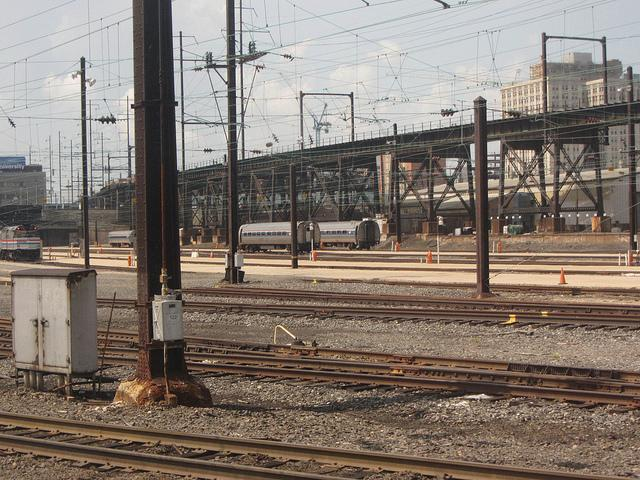What mode of transport is in the picture above? train 